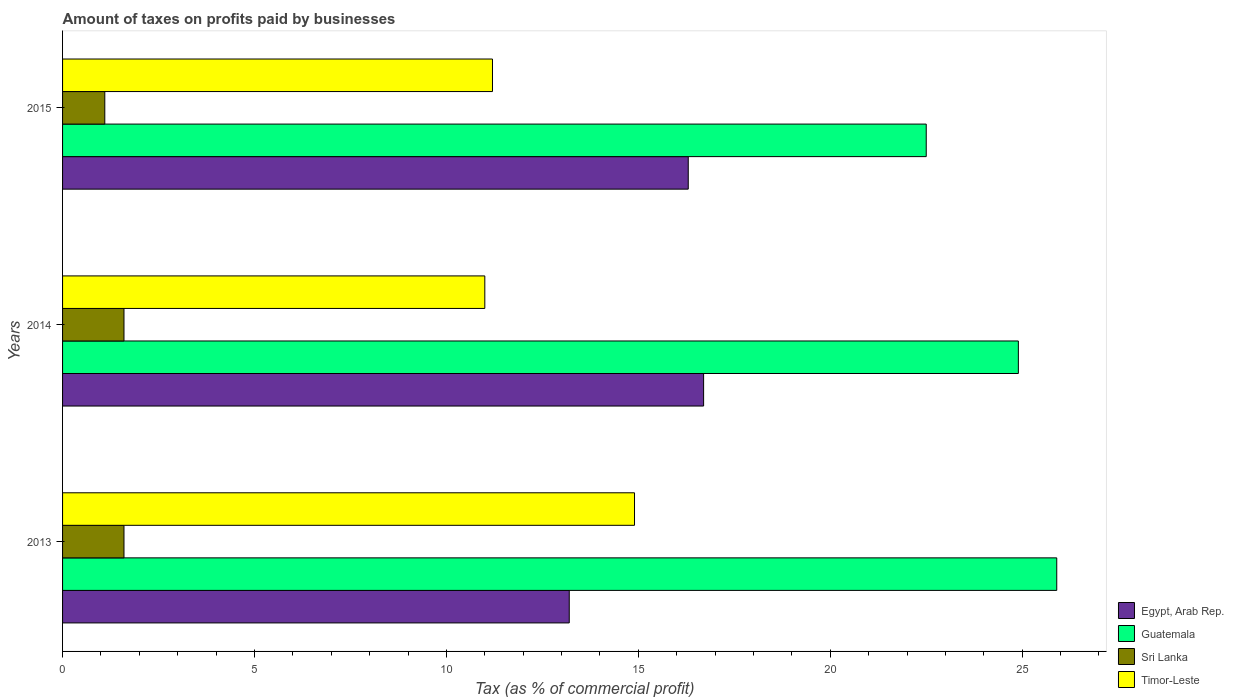Are the number of bars per tick equal to the number of legend labels?
Your answer should be very brief. Yes. Are the number of bars on each tick of the Y-axis equal?
Ensure brevity in your answer.  Yes. How many bars are there on the 1st tick from the bottom?
Offer a terse response. 4. What is the label of the 1st group of bars from the top?
Give a very brief answer. 2015. Across all years, what is the maximum percentage of taxes paid by businesses in Guatemala?
Ensure brevity in your answer.  25.9. Across all years, what is the minimum percentage of taxes paid by businesses in Timor-Leste?
Provide a short and direct response. 11. In which year was the percentage of taxes paid by businesses in Timor-Leste maximum?
Ensure brevity in your answer.  2013. What is the total percentage of taxes paid by businesses in Sri Lanka in the graph?
Your answer should be very brief. 4.3. What is the difference between the percentage of taxes paid by businesses in Timor-Leste in 2013 and that in 2014?
Your answer should be very brief. 3.9. What is the difference between the percentage of taxes paid by businesses in Egypt, Arab Rep. in 2014 and the percentage of taxes paid by businesses in Guatemala in 2015?
Keep it short and to the point. -5.8. What is the average percentage of taxes paid by businesses in Sri Lanka per year?
Your answer should be compact. 1.43. In the year 2013, what is the difference between the percentage of taxes paid by businesses in Sri Lanka and percentage of taxes paid by businesses in Timor-Leste?
Give a very brief answer. -13.3. In how many years, is the percentage of taxes paid by businesses in Guatemala greater than 19 %?
Offer a very short reply. 3. What is the ratio of the percentage of taxes paid by businesses in Timor-Leste in 2014 to that in 2015?
Offer a very short reply. 0.98. Is the difference between the percentage of taxes paid by businesses in Sri Lanka in 2014 and 2015 greater than the difference between the percentage of taxes paid by businesses in Timor-Leste in 2014 and 2015?
Your response must be concise. Yes. What is the difference between the highest and the second highest percentage of taxes paid by businesses in Sri Lanka?
Keep it short and to the point. 0. What is the difference between the highest and the lowest percentage of taxes paid by businesses in Guatemala?
Make the answer very short. 3.4. Is the sum of the percentage of taxes paid by businesses in Timor-Leste in 2014 and 2015 greater than the maximum percentage of taxes paid by businesses in Sri Lanka across all years?
Offer a terse response. Yes. Is it the case that in every year, the sum of the percentage of taxes paid by businesses in Sri Lanka and percentage of taxes paid by businesses in Egypt, Arab Rep. is greater than the sum of percentage of taxes paid by businesses in Timor-Leste and percentage of taxes paid by businesses in Guatemala?
Offer a terse response. No. What does the 3rd bar from the top in 2014 represents?
Offer a very short reply. Guatemala. What does the 4th bar from the bottom in 2015 represents?
Keep it short and to the point. Timor-Leste. Is it the case that in every year, the sum of the percentage of taxes paid by businesses in Guatemala and percentage of taxes paid by businesses in Sri Lanka is greater than the percentage of taxes paid by businesses in Egypt, Arab Rep.?
Give a very brief answer. Yes. How many bars are there?
Offer a very short reply. 12. Does the graph contain any zero values?
Your answer should be compact. No. Where does the legend appear in the graph?
Ensure brevity in your answer.  Bottom right. How are the legend labels stacked?
Offer a very short reply. Vertical. What is the title of the graph?
Your answer should be very brief. Amount of taxes on profits paid by businesses. Does "Heavily indebted poor countries" appear as one of the legend labels in the graph?
Ensure brevity in your answer.  No. What is the label or title of the X-axis?
Your answer should be compact. Tax (as % of commercial profit). What is the label or title of the Y-axis?
Make the answer very short. Years. What is the Tax (as % of commercial profit) of Guatemala in 2013?
Your answer should be compact. 25.9. What is the Tax (as % of commercial profit) in Sri Lanka in 2013?
Keep it short and to the point. 1.6. What is the Tax (as % of commercial profit) in Guatemala in 2014?
Provide a short and direct response. 24.9. What is the Tax (as % of commercial profit) in Sri Lanka in 2014?
Your answer should be very brief. 1.6. What is the Tax (as % of commercial profit) of Timor-Leste in 2014?
Your answer should be very brief. 11. What is the Tax (as % of commercial profit) of Egypt, Arab Rep. in 2015?
Offer a terse response. 16.3. What is the Tax (as % of commercial profit) of Sri Lanka in 2015?
Your answer should be compact. 1.1. Across all years, what is the maximum Tax (as % of commercial profit) of Guatemala?
Ensure brevity in your answer.  25.9. Across all years, what is the maximum Tax (as % of commercial profit) in Timor-Leste?
Make the answer very short. 14.9. Across all years, what is the minimum Tax (as % of commercial profit) of Egypt, Arab Rep.?
Keep it short and to the point. 13.2. Across all years, what is the minimum Tax (as % of commercial profit) of Guatemala?
Make the answer very short. 22.5. Across all years, what is the minimum Tax (as % of commercial profit) of Sri Lanka?
Provide a short and direct response. 1.1. What is the total Tax (as % of commercial profit) of Egypt, Arab Rep. in the graph?
Make the answer very short. 46.2. What is the total Tax (as % of commercial profit) in Guatemala in the graph?
Keep it short and to the point. 73.3. What is the total Tax (as % of commercial profit) of Sri Lanka in the graph?
Offer a very short reply. 4.3. What is the total Tax (as % of commercial profit) of Timor-Leste in the graph?
Your answer should be compact. 37.1. What is the difference between the Tax (as % of commercial profit) of Egypt, Arab Rep. in 2013 and that in 2014?
Give a very brief answer. -3.5. What is the difference between the Tax (as % of commercial profit) of Guatemala in 2013 and that in 2014?
Give a very brief answer. 1. What is the difference between the Tax (as % of commercial profit) of Sri Lanka in 2013 and that in 2014?
Give a very brief answer. 0. What is the difference between the Tax (as % of commercial profit) in Egypt, Arab Rep. in 2013 and that in 2015?
Make the answer very short. -3.1. What is the difference between the Tax (as % of commercial profit) in Timor-Leste in 2013 and that in 2015?
Give a very brief answer. 3.7. What is the difference between the Tax (as % of commercial profit) of Egypt, Arab Rep. in 2014 and that in 2015?
Offer a very short reply. 0.4. What is the difference between the Tax (as % of commercial profit) of Guatemala in 2014 and that in 2015?
Your answer should be compact. 2.4. What is the difference between the Tax (as % of commercial profit) in Egypt, Arab Rep. in 2013 and the Tax (as % of commercial profit) in Timor-Leste in 2014?
Give a very brief answer. 2.2. What is the difference between the Tax (as % of commercial profit) of Guatemala in 2013 and the Tax (as % of commercial profit) of Sri Lanka in 2014?
Your response must be concise. 24.3. What is the difference between the Tax (as % of commercial profit) in Guatemala in 2013 and the Tax (as % of commercial profit) in Timor-Leste in 2014?
Provide a succinct answer. 14.9. What is the difference between the Tax (as % of commercial profit) of Sri Lanka in 2013 and the Tax (as % of commercial profit) of Timor-Leste in 2014?
Offer a terse response. -9.4. What is the difference between the Tax (as % of commercial profit) in Egypt, Arab Rep. in 2013 and the Tax (as % of commercial profit) in Guatemala in 2015?
Your answer should be very brief. -9.3. What is the difference between the Tax (as % of commercial profit) in Egypt, Arab Rep. in 2013 and the Tax (as % of commercial profit) in Timor-Leste in 2015?
Provide a succinct answer. 2. What is the difference between the Tax (as % of commercial profit) of Guatemala in 2013 and the Tax (as % of commercial profit) of Sri Lanka in 2015?
Offer a very short reply. 24.8. What is the difference between the Tax (as % of commercial profit) of Egypt, Arab Rep. in 2014 and the Tax (as % of commercial profit) of Timor-Leste in 2015?
Offer a very short reply. 5.5. What is the difference between the Tax (as % of commercial profit) of Guatemala in 2014 and the Tax (as % of commercial profit) of Sri Lanka in 2015?
Your answer should be compact. 23.8. What is the difference between the Tax (as % of commercial profit) in Sri Lanka in 2014 and the Tax (as % of commercial profit) in Timor-Leste in 2015?
Provide a short and direct response. -9.6. What is the average Tax (as % of commercial profit) in Guatemala per year?
Ensure brevity in your answer.  24.43. What is the average Tax (as % of commercial profit) in Sri Lanka per year?
Provide a short and direct response. 1.43. What is the average Tax (as % of commercial profit) in Timor-Leste per year?
Your response must be concise. 12.37. In the year 2013, what is the difference between the Tax (as % of commercial profit) of Egypt, Arab Rep. and Tax (as % of commercial profit) of Guatemala?
Give a very brief answer. -12.7. In the year 2013, what is the difference between the Tax (as % of commercial profit) in Egypt, Arab Rep. and Tax (as % of commercial profit) in Sri Lanka?
Offer a very short reply. 11.6. In the year 2013, what is the difference between the Tax (as % of commercial profit) of Egypt, Arab Rep. and Tax (as % of commercial profit) of Timor-Leste?
Provide a short and direct response. -1.7. In the year 2013, what is the difference between the Tax (as % of commercial profit) in Guatemala and Tax (as % of commercial profit) in Sri Lanka?
Offer a terse response. 24.3. In the year 2014, what is the difference between the Tax (as % of commercial profit) in Egypt, Arab Rep. and Tax (as % of commercial profit) in Sri Lanka?
Your response must be concise. 15.1. In the year 2014, what is the difference between the Tax (as % of commercial profit) in Egypt, Arab Rep. and Tax (as % of commercial profit) in Timor-Leste?
Keep it short and to the point. 5.7. In the year 2014, what is the difference between the Tax (as % of commercial profit) of Guatemala and Tax (as % of commercial profit) of Sri Lanka?
Your answer should be compact. 23.3. In the year 2015, what is the difference between the Tax (as % of commercial profit) of Guatemala and Tax (as % of commercial profit) of Sri Lanka?
Your answer should be compact. 21.4. What is the ratio of the Tax (as % of commercial profit) in Egypt, Arab Rep. in 2013 to that in 2014?
Offer a very short reply. 0.79. What is the ratio of the Tax (as % of commercial profit) in Guatemala in 2013 to that in 2014?
Ensure brevity in your answer.  1.04. What is the ratio of the Tax (as % of commercial profit) of Timor-Leste in 2013 to that in 2014?
Offer a very short reply. 1.35. What is the ratio of the Tax (as % of commercial profit) of Egypt, Arab Rep. in 2013 to that in 2015?
Provide a short and direct response. 0.81. What is the ratio of the Tax (as % of commercial profit) in Guatemala in 2013 to that in 2015?
Keep it short and to the point. 1.15. What is the ratio of the Tax (as % of commercial profit) in Sri Lanka in 2013 to that in 2015?
Ensure brevity in your answer.  1.45. What is the ratio of the Tax (as % of commercial profit) in Timor-Leste in 2013 to that in 2015?
Your answer should be very brief. 1.33. What is the ratio of the Tax (as % of commercial profit) of Egypt, Arab Rep. in 2014 to that in 2015?
Your answer should be compact. 1.02. What is the ratio of the Tax (as % of commercial profit) in Guatemala in 2014 to that in 2015?
Your answer should be very brief. 1.11. What is the ratio of the Tax (as % of commercial profit) in Sri Lanka in 2014 to that in 2015?
Offer a terse response. 1.45. What is the ratio of the Tax (as % of commercial profit) in Timor-Leste in 2014 to that in 2015?
Offer a very short reply. 0.98. What is the difference between the highest and the second highest Tax (as % of commercial profit) in Egypt, Arab Rep.?
Offer a terse response. 0.4. What is the difference between the highest and the second highest Tax (as % of commercial profit) of Sri Lanka?
Your answer should be very brief. 0. What is the difference between the highest and the second highest Tax (as % of commercial profit) of Timor-Leste?
Make the answer very short. 3.7. What is the difference between the highest and the lowest Tax (as % of commercial profit) in Sri Lanka?
Keep it short and to the point. 0.5. 